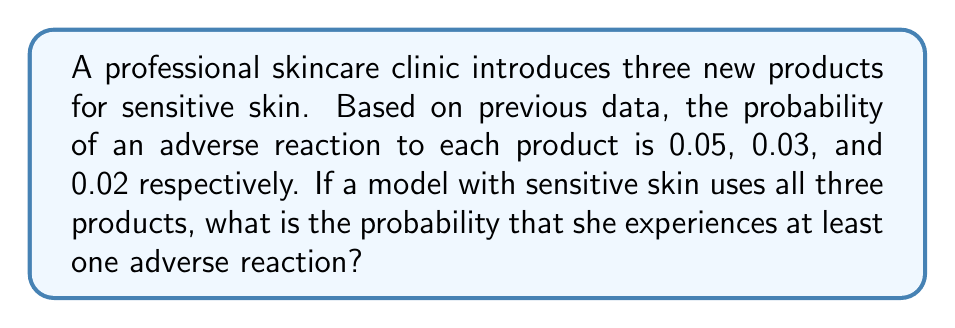Could you help me with this problem? Let's approach this step-by-step:

1) First, we need to calculate the probability of not having an adverse reaction to each product:
   Product 1: $1 - 0.05 = 0.95$
   Product 2: $1 - 0.03 = 0.97$
   Product 3: $1 - 0.02 = 0.98$

2) The probability of not having an adverse reaction to any of the products is the product of these individual probabilities:
   $$P(\text{no reaction}) = 0.95 \times 0.97 \times 0.98 = 0.9030$$

3) Therefore, the probability of having at least one adverse reaction is the complement of this probability:
   $$P(\text{at least one reaction}) = 1 - P(\text{no reaction})$$
   $$P(\text{at least one reaction}) = 1 - 0.9030 = 0.0970$$

4) We can express this as a percentage:
   $$0.0970 \times 100\% = 9.70\%$$
Answer: 9.70% 